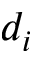<formula> <loc_0><loc_0><loc_500><loc_500>d _ { i }</formula> 